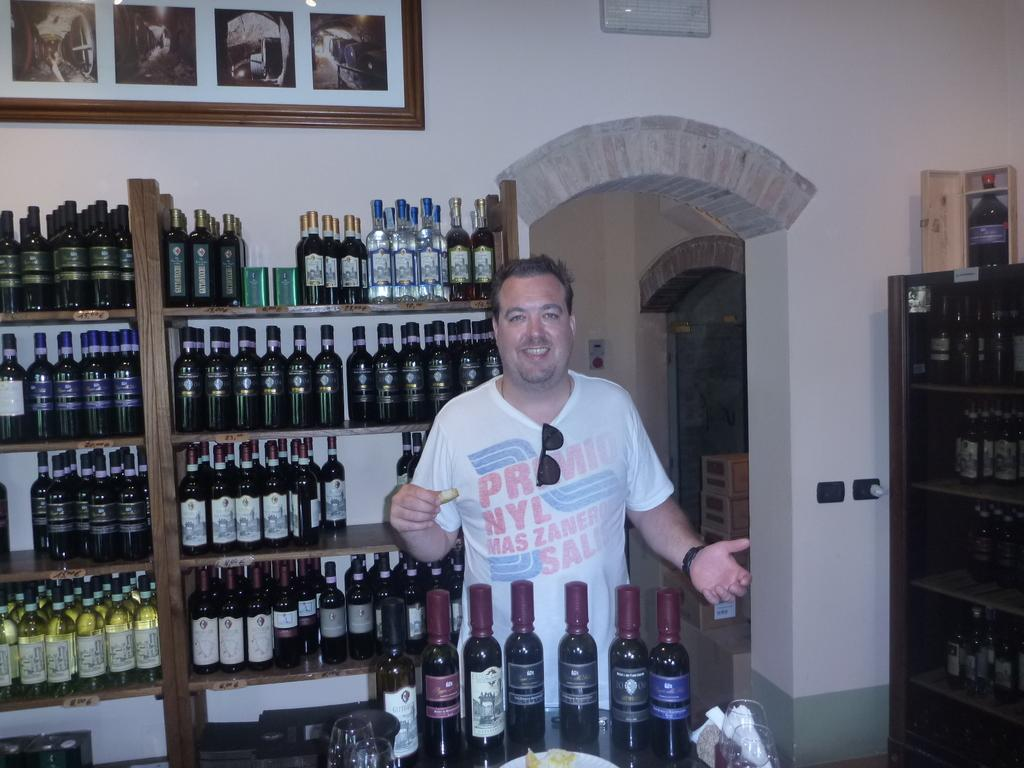<image>
Present a compact description of the photo's key features. a person's shirt that has NYL written on it 